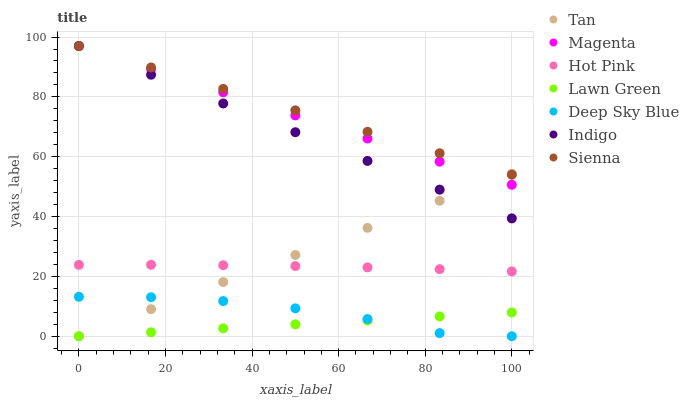Does Lawn Green have the minimum area under the curve?
Answer yes or no. Yes. Does Sienna have the maximum area under the curve?
Answer yes or no. Yes. Does Indigo have the minimum area under the curve?
Answer yes or no. No. Does Indigo have the maximum area under the curve?
Answer yes or no. No. Is Lawn Green the smoothest?
Answer yes or no. Yes. Is Deep Sky Blue the roughest?
Answer yes or no. Yes. Is Indigo the smoothest?
Answer yes or no. No. Is Indigo the roughest?
Answer yes or no. No. Does Lawn Green have the lowest value?
Answer yes or no. Yes. Does Indigo have the lowest value?
Answer yes or no. No. Does Magenta have the highest value?
Answer yes or no. Yes. Does Hot Pink have the highest value?
Answer yes or no. No. Is Hot Pink less than Magenta?
Answer yes or no. Yes. Is Indigo greater than Deep Sky Blue?
Answer yes or no. Yes. Does Magenta intersect Indigo?
Answer yes or no. Yes. Is Magenta less than Indigo?
Answer yes or no. No. Is Magenta greater than Indigo?
Answer yes or no. No. Does Hot Pink intersect Magenta?
Answer yes or no. No. 